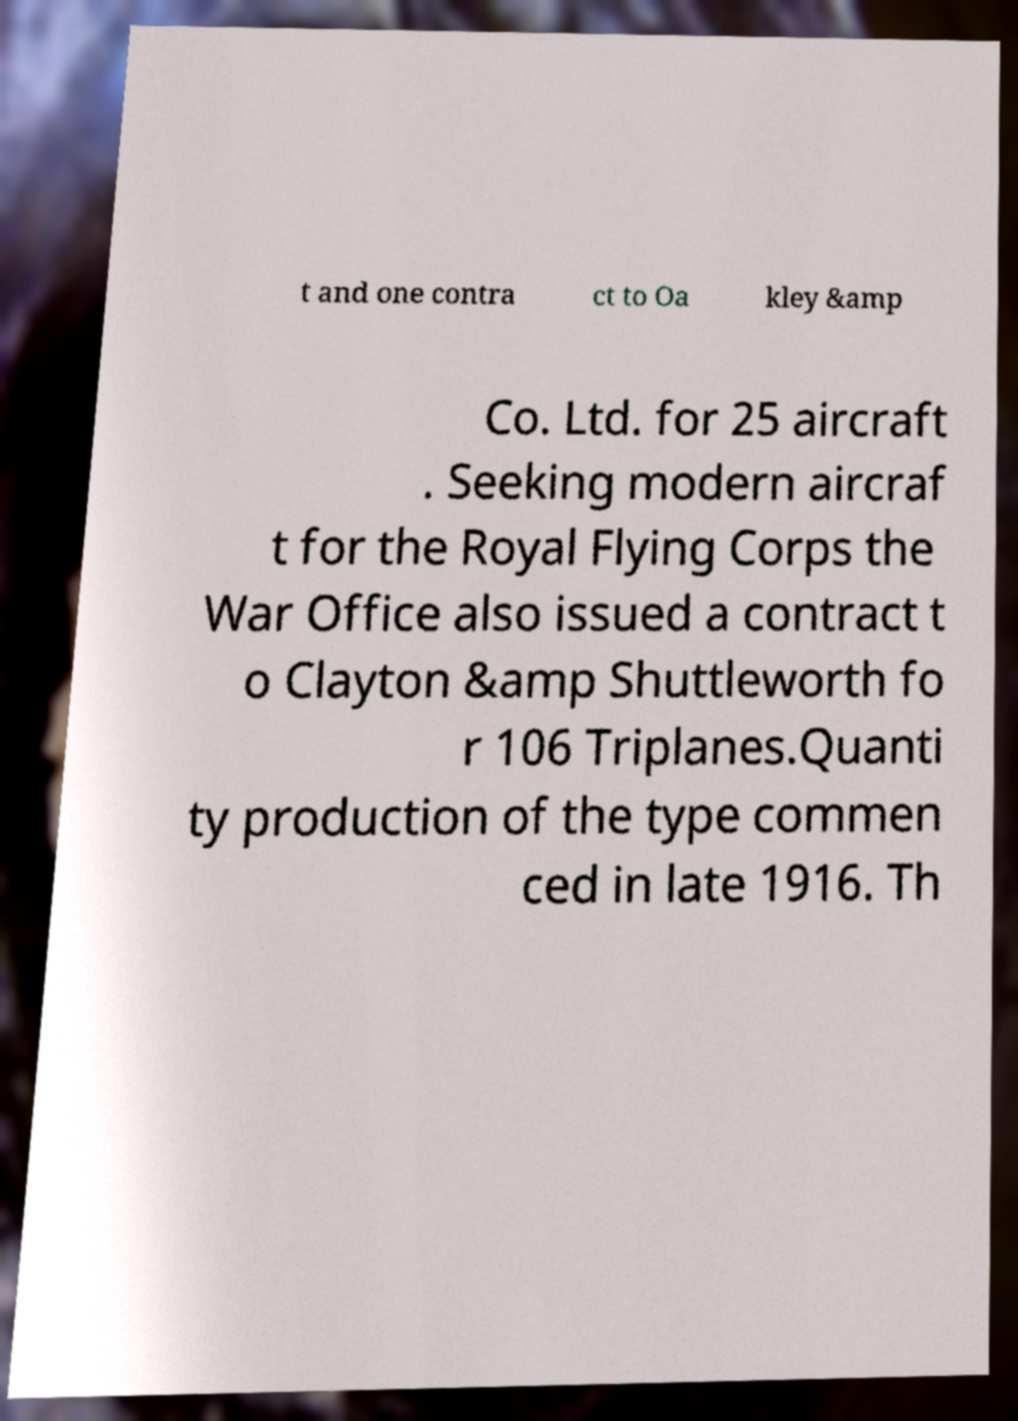Can you read and provide the text displayed in the image?This photo seems to have some interesting text. Can you extract and type it out for me? t and one contra ct to Oa kley &amp Co. Ltd. for 25 aircraft . Seeking modern aircraf t for the Royal Flying Corps the War Office also issued a contract t o Clayton &amp Shuttleworth fo r 106 Triplanes.Quanti ty production of the type commen ced in late 1916. Th 